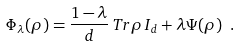<formula> <loc_0><loc_0><loc_500><loc_500>\Phi _ { \lambda } ( \rho ) = \frac { 1 - \lambda } { d } \, T r \rho \, I _ { d } + \lambda \Psi ( \rho ) \ .</formula> 